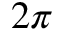Convert formula to latex. <formula><loc_0><loc_0><loc_500><loc_500>2 \pi</formula> 